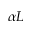<formula> <loc_0><loc_0><loc_500><loc_500>\alpha L</formula> 